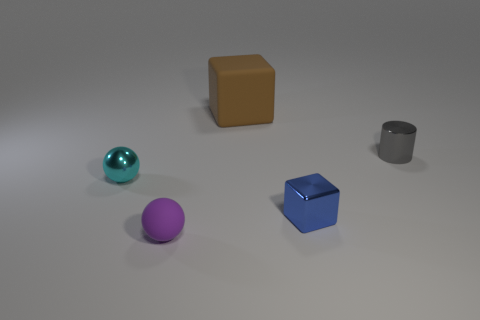The blue block that is the same material as the cylinder is what size?
Ensure brevity in your answer.  Small. What number of metal blocks are left of the tiny metal object that is on the right side of the tiny blue cube?
Give a very brief answer. 1. Does the block that is behind the tiny cyan thing have the same material as the blue block?
Your answer should be very brief. No. Is there anything else that is made of the same material as the tiny cyan thing?
Your answer should be compact. Yes. There is a rubber thing that is behind the small metallic object left of the large object; what is its size?
Make the answer very short. Large. What size is the ball that is on the right side of the small shiny thing to the left of the brown block to the right of the purple rubber thing?
Offer a terse response. Small. Do the metallic thing behind the small metallic ball and the rubber thing that is behind the cyan object have the same shape?
Give a very brief answer. No. Does the rubber thing that is in front of the metal cylinder have the same size as the tiny gray metallic cylinder?
Keep it short and to the point. Yes. Is the material of the block behind the tiny gray cylinder the same as the small gray object that is to the right of the tiny shiny sphere?
Offer a very short reply. No. Are there any cyan things that have the same size as the brown object?
Offer a terse response. No. 